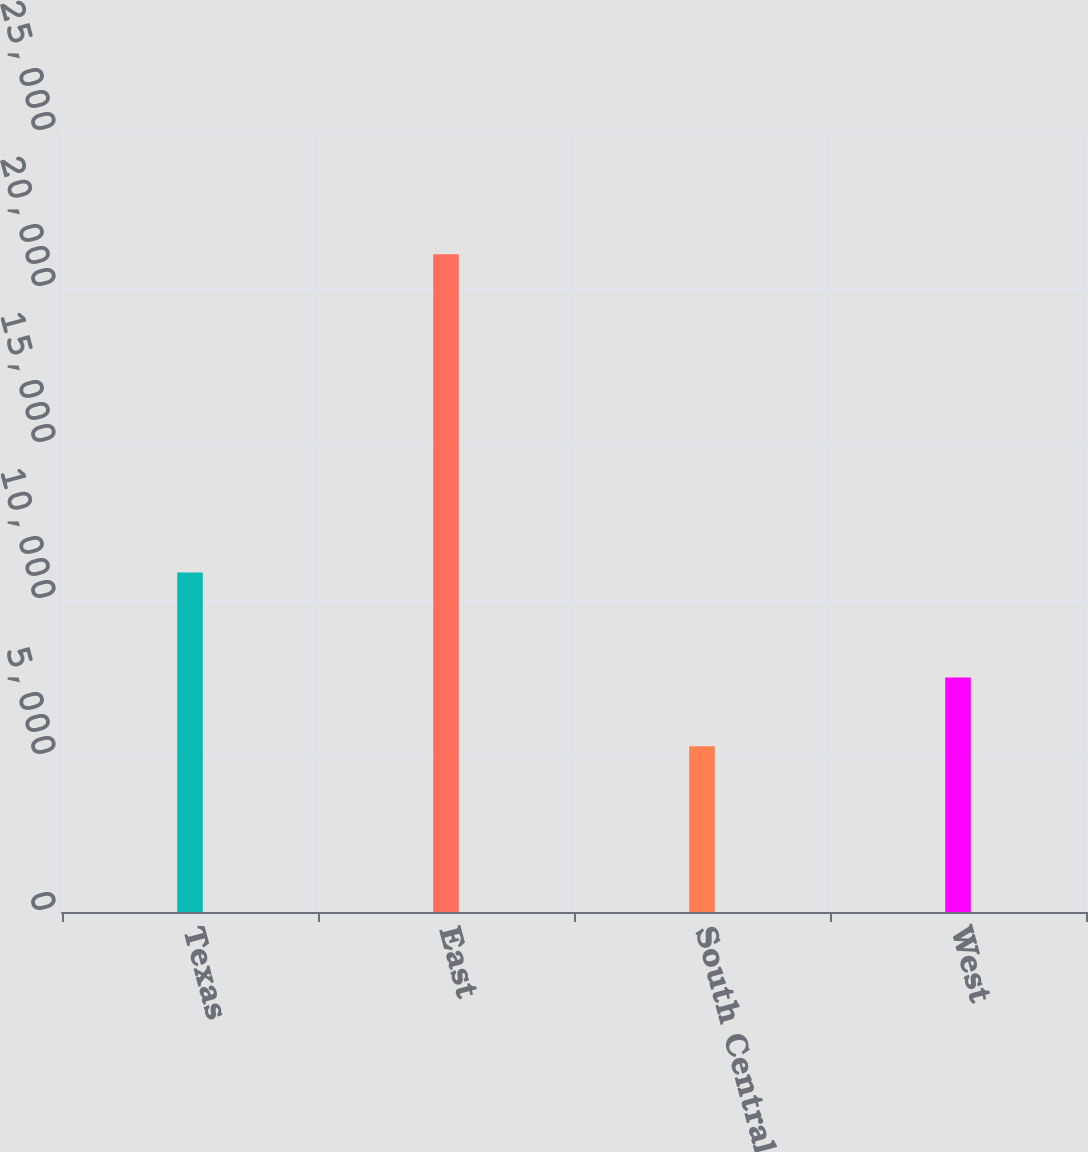<chart> <loc_0><loc_0><loc_500><loc_500><bar_chart><fcel>Texas<fcel>East<fcel>South Central<fcel>West<nl><fcel>10880<fcel>21080<fcel>5315<fcel>7520<nl></chart> 